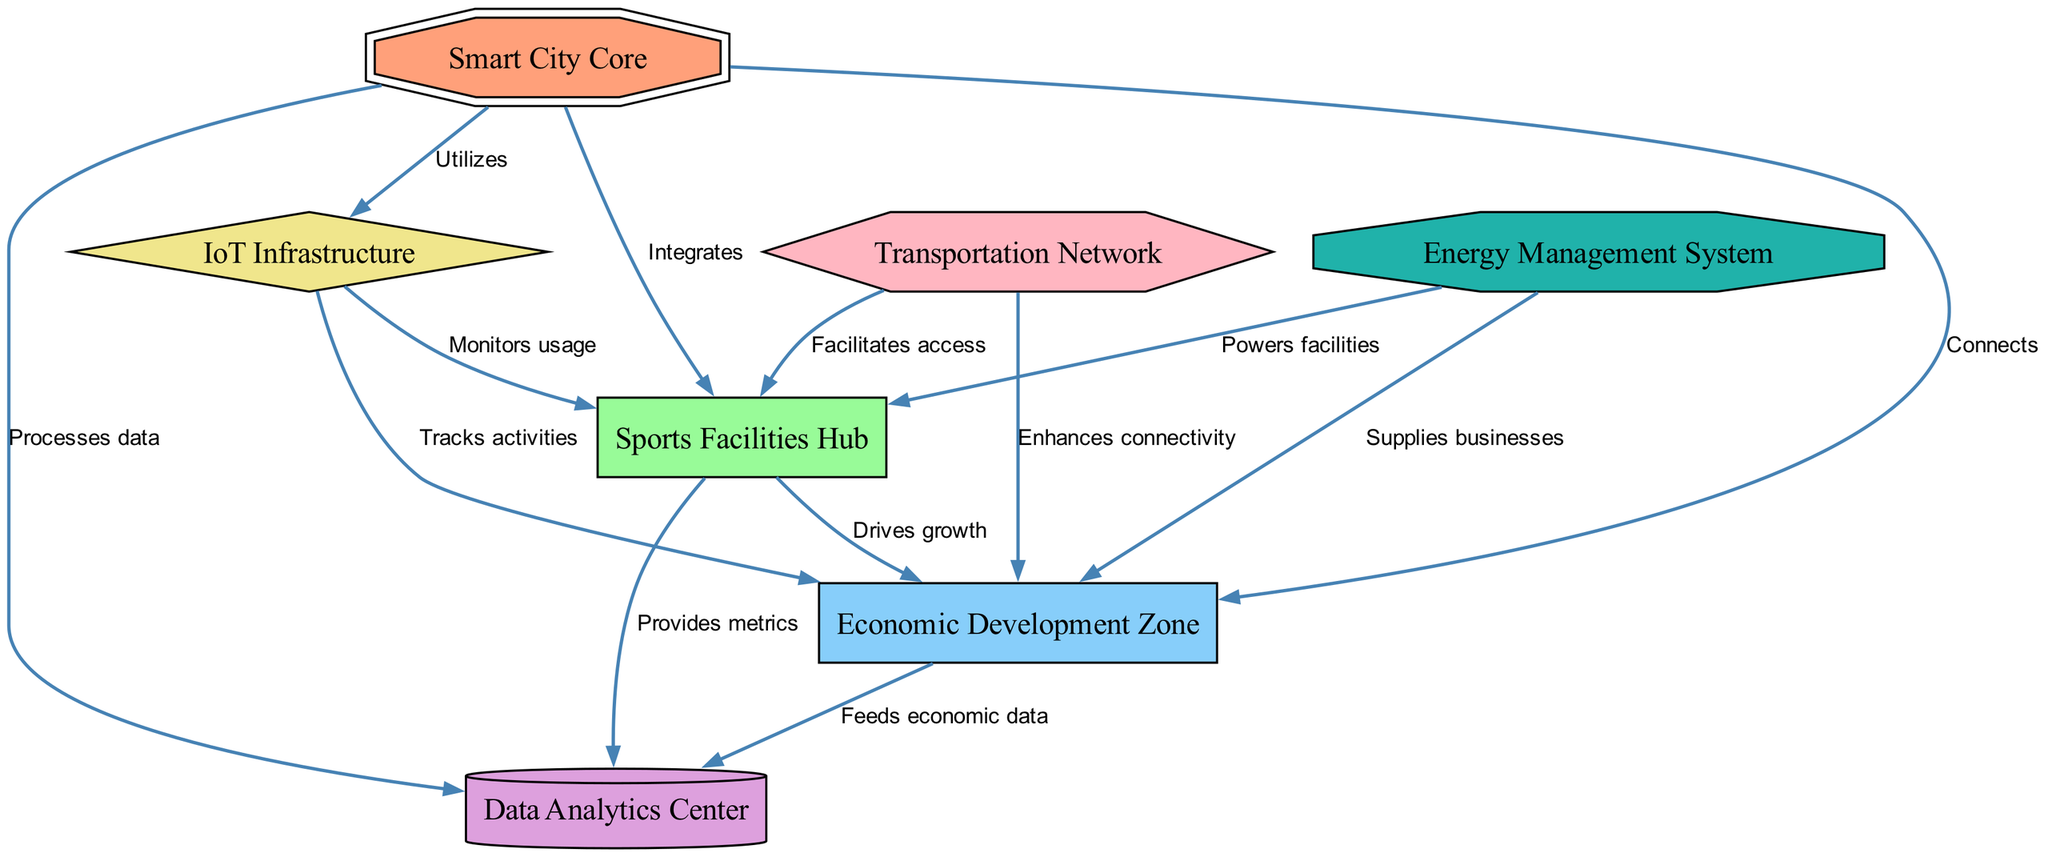What is the central node in the diagram? The central node, often referred to as the main point of control in the diagram, is identified as the "Smart City Core". It is typically where the integration of all systems occurs.
Answer: Smart City Core How many nodes are present in the diagram? By counting all the unique entities depicted in the diagram, there are a total of seven nodes that are part of the systems architecture specified.
Answer: 7 What is the relationship between the "Sports Facilities Hub" and the "Economic Development Zone"? The diagram shows a directed edge between these two nodes labeled "Drives growth," indicating that the Sports Facilities Hub contributes positively to the Economic Development Zone.
Answer: Drives growth Which system powers the "Sports Facilities Hub"? The edge leading from "Energy Management System" to "Sports Facilities Hub" is labeled "Powers facilities," indicating that this is the system that provides energy to the sports facilities.
Answer: Powers facilities What role does the "Data Analytics Center" play in the diagram? The Data Analytics Center is connected to multiple nodes, but specifically, it has a relationship with the "Smart City Core" labeled "Processes data," which suggests it is primarily involved in data processing for the entire smart city framework.
Answer: Processes data How does the "IoT Infrastructure" contribute to "Sports Facilities Hub"? The relationship is illustrated by an edge labeled "Monitors usage," meaning the IoT Infrastructure tracks or manages the usage data for the Sports Facilities Hub, helping in operational decisions.
Answer: Monitors usage What enhances connectivity to the "Economic Development Zone"? The diagram indicates that the "Transportation Network" is linked to the "Economic Development Zone" with an edge labeled "Enhances connectivity," suggesting it plays a critical role in improving accessibility to the economic area.
Answer: Enhances connectivity Which component feeds data to the "Data Analytics Center"? The directed edge from "Economic Development Zone" to "Data Analytics Center" is labeled "Feeds economic data," indicating that it is the source of information for the Data Analytics Center, contributing inputs for analysis.
Answer: Feeds economic data 